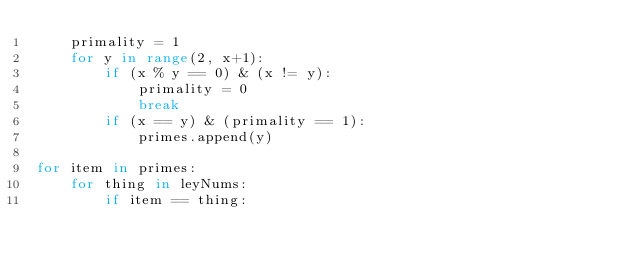<code> <loc_0><loc_0><loc_500><loc_500><_Python_>    primality = 1
    for y in range(2, x+1):
        if (x % y == 0) & (x != y):
            primality = 0
            break
        if (x == y) & (primality == 1):
            primes.append(y)

for item in primes:
    for thing in leyNums:
        if item == thing:</code> 